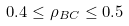Convert formula to latex. <formula><loc_0><loc_0><loc_500><loc_500>0 . 4 \leq \rho _ { B C } \leq 0 . 5</formula> 